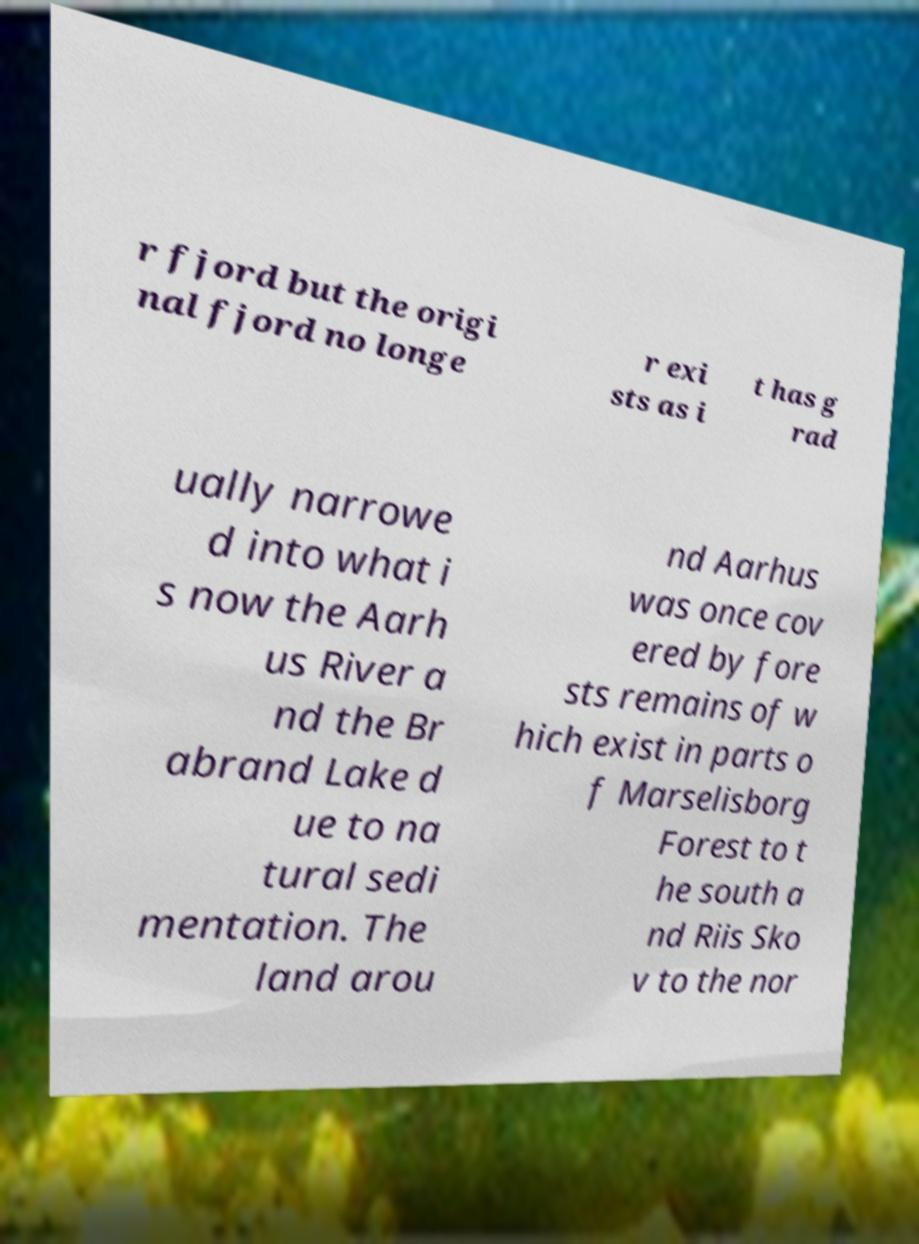Could you assist in decoding the text presented in this image and type it out clearly? r fjord but the origi nal fjord no longe r exi sts as i t has g rad ually narrowe d into what i s now the Aarh us River a nd the Br abrand Lake d ue to na tural sedi mentation. The land arou nd Aarhus was once cov ered by fore sts remains of w hich exist in parts o f Marselisborg Forest to t he south a nd Riis Sko v to the nor 